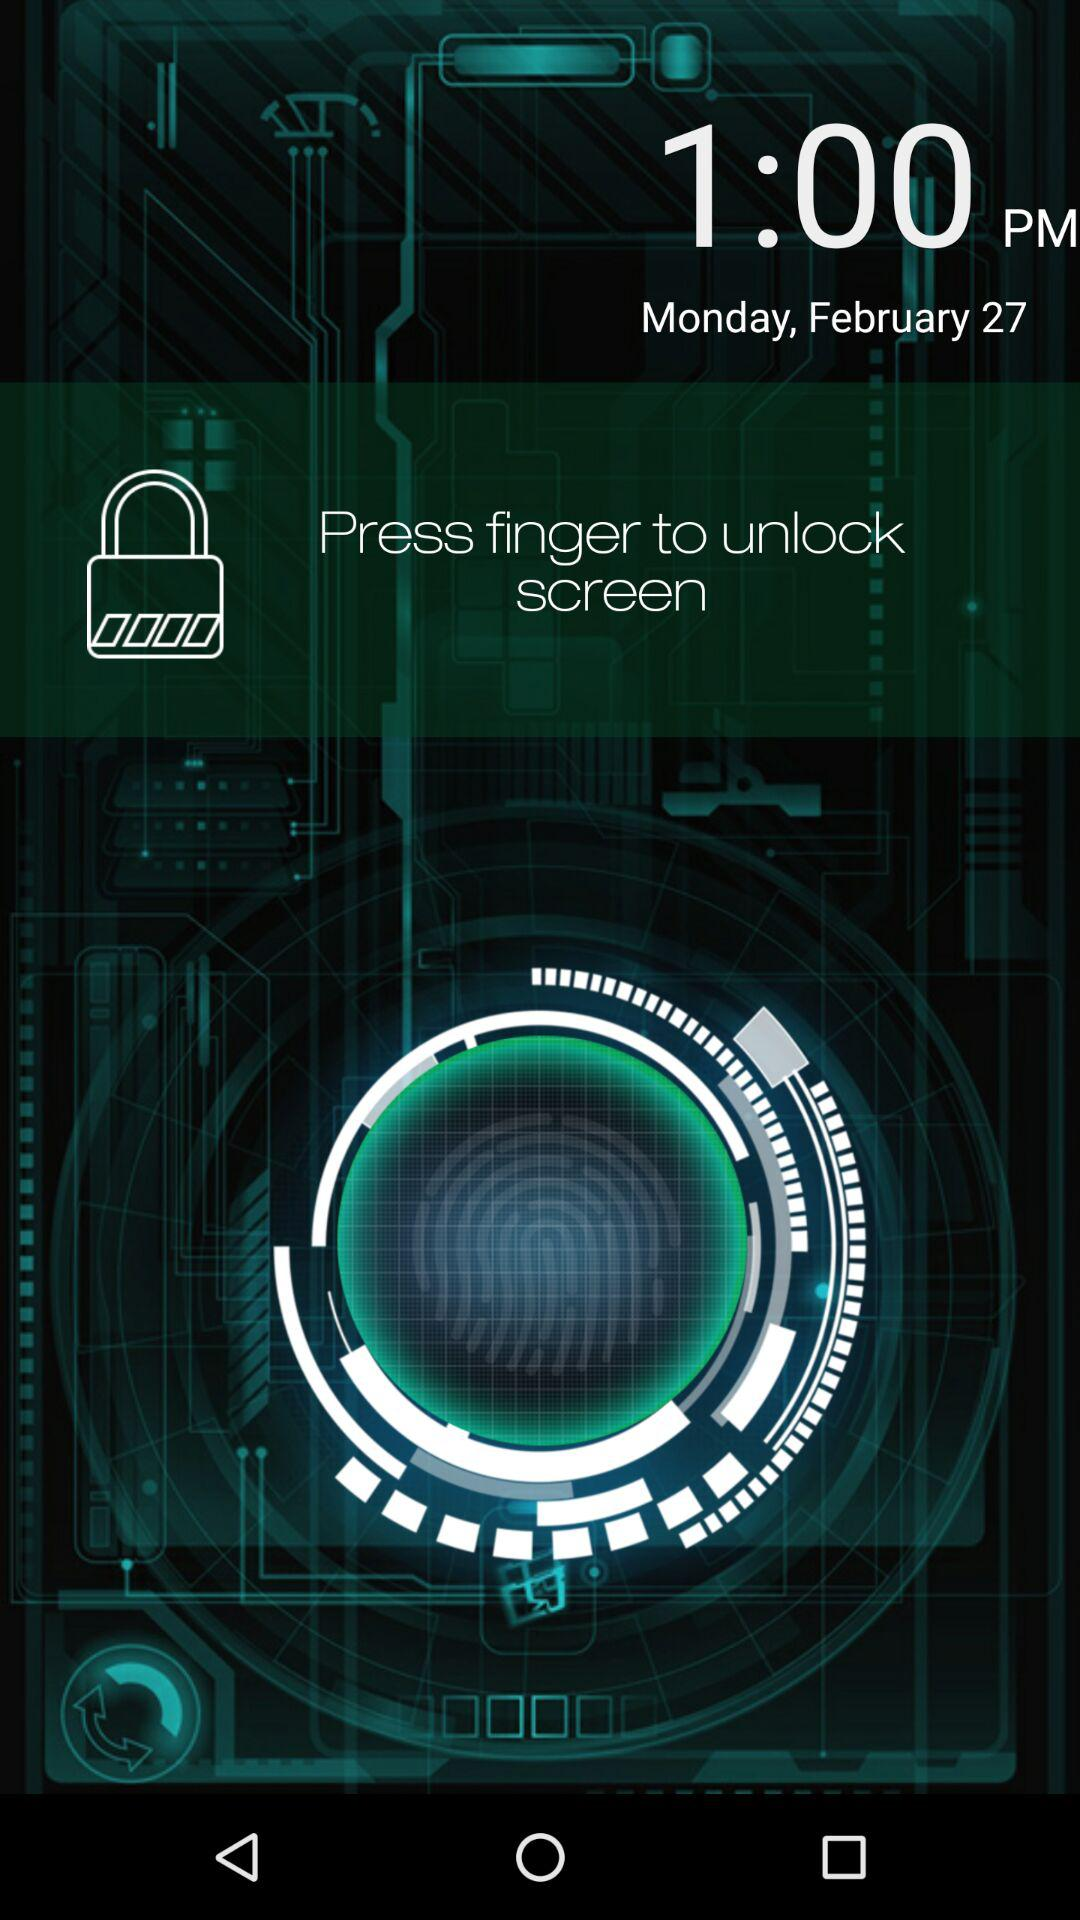What is the mentioned time? The mentioned time is 1:00 PM. 